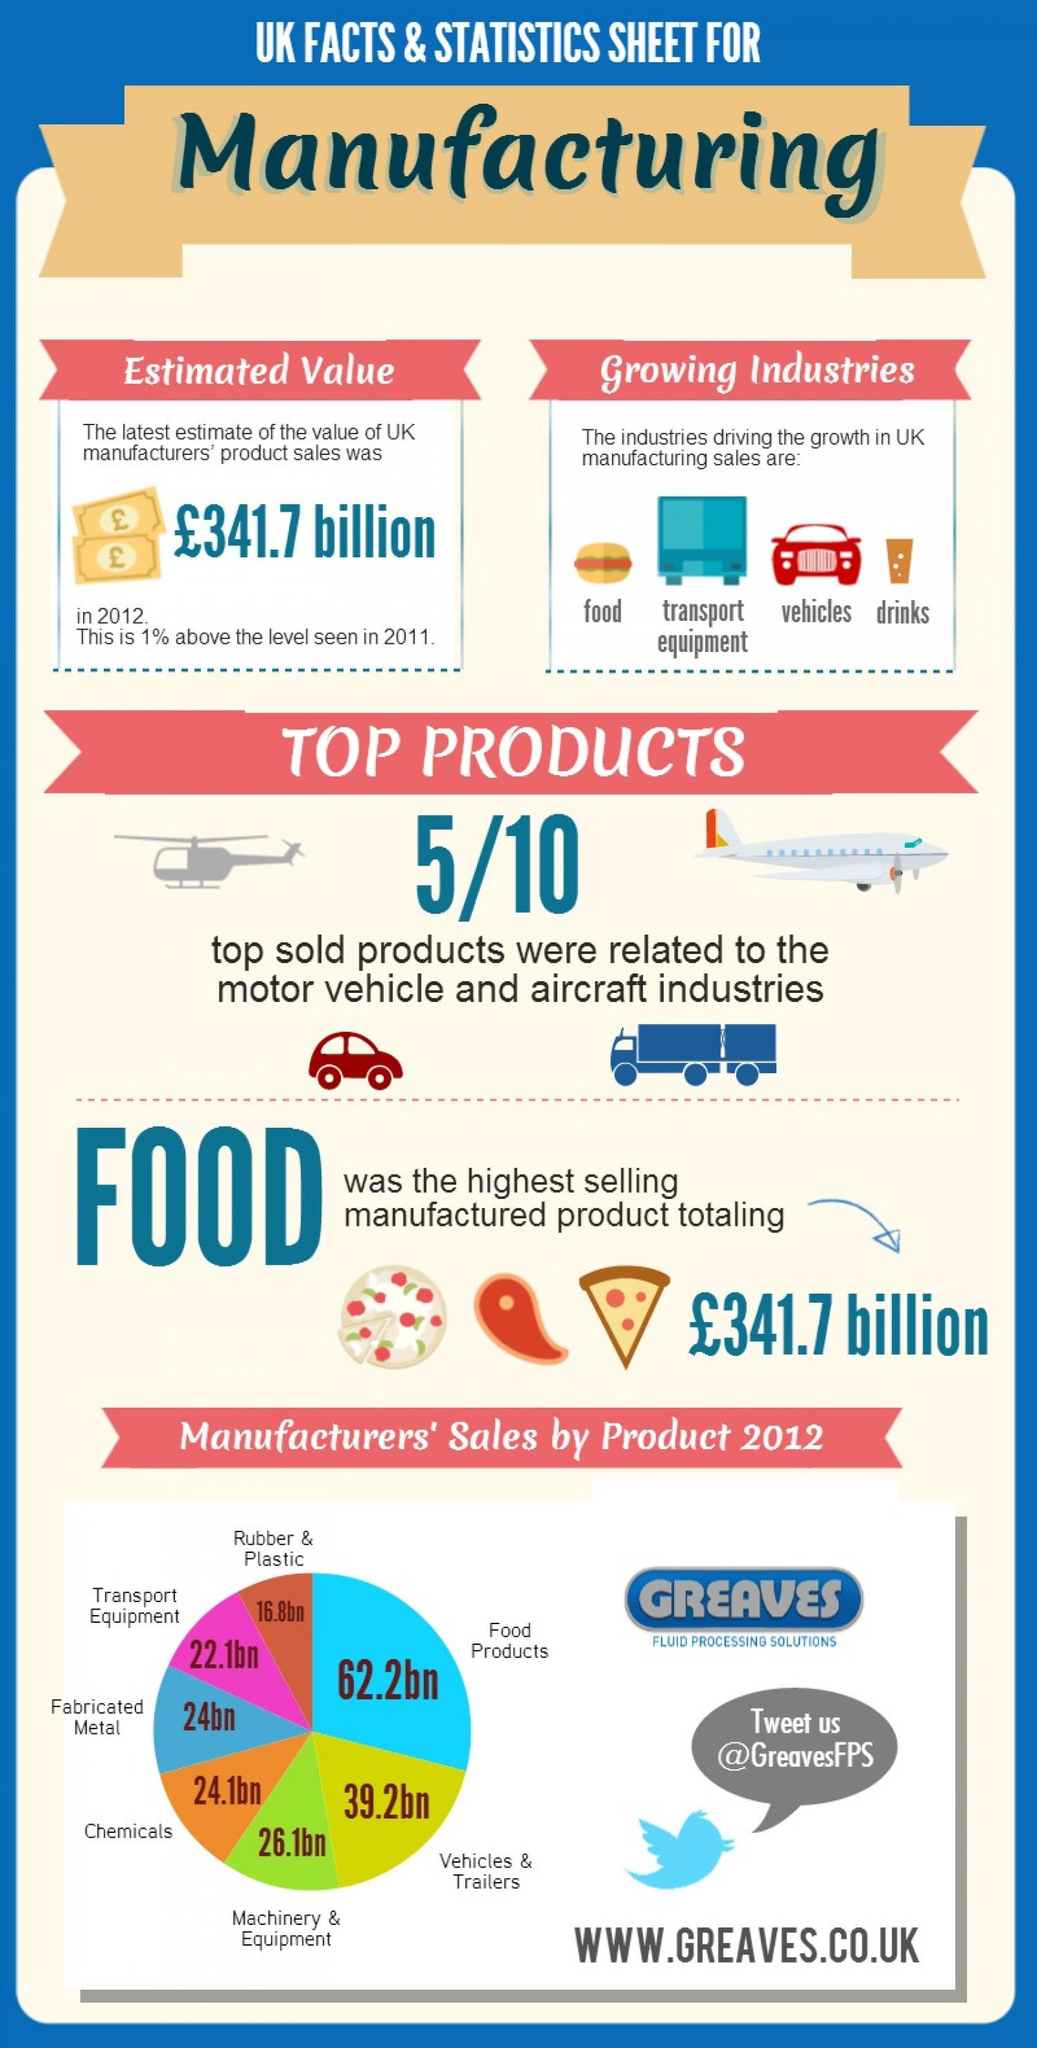Identify some key points in this picture. According to estimates, the value at which Rubber & Plastic was manufactured in the UK was 16.8 billion. The estimated value of food manufacturing in the UK is £341.7 billion. The highest selling manufactured product in the UK is food. In the UK, the estimated value of chemicals manufacturing was 24.1 billion. The second highest selling manufactured product in the UK is vehicles and trailers. 